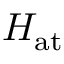Convert formula to latex. <formula><loc_0><loc_0><loc_500><loc_500>H _ { a t }</formula> 